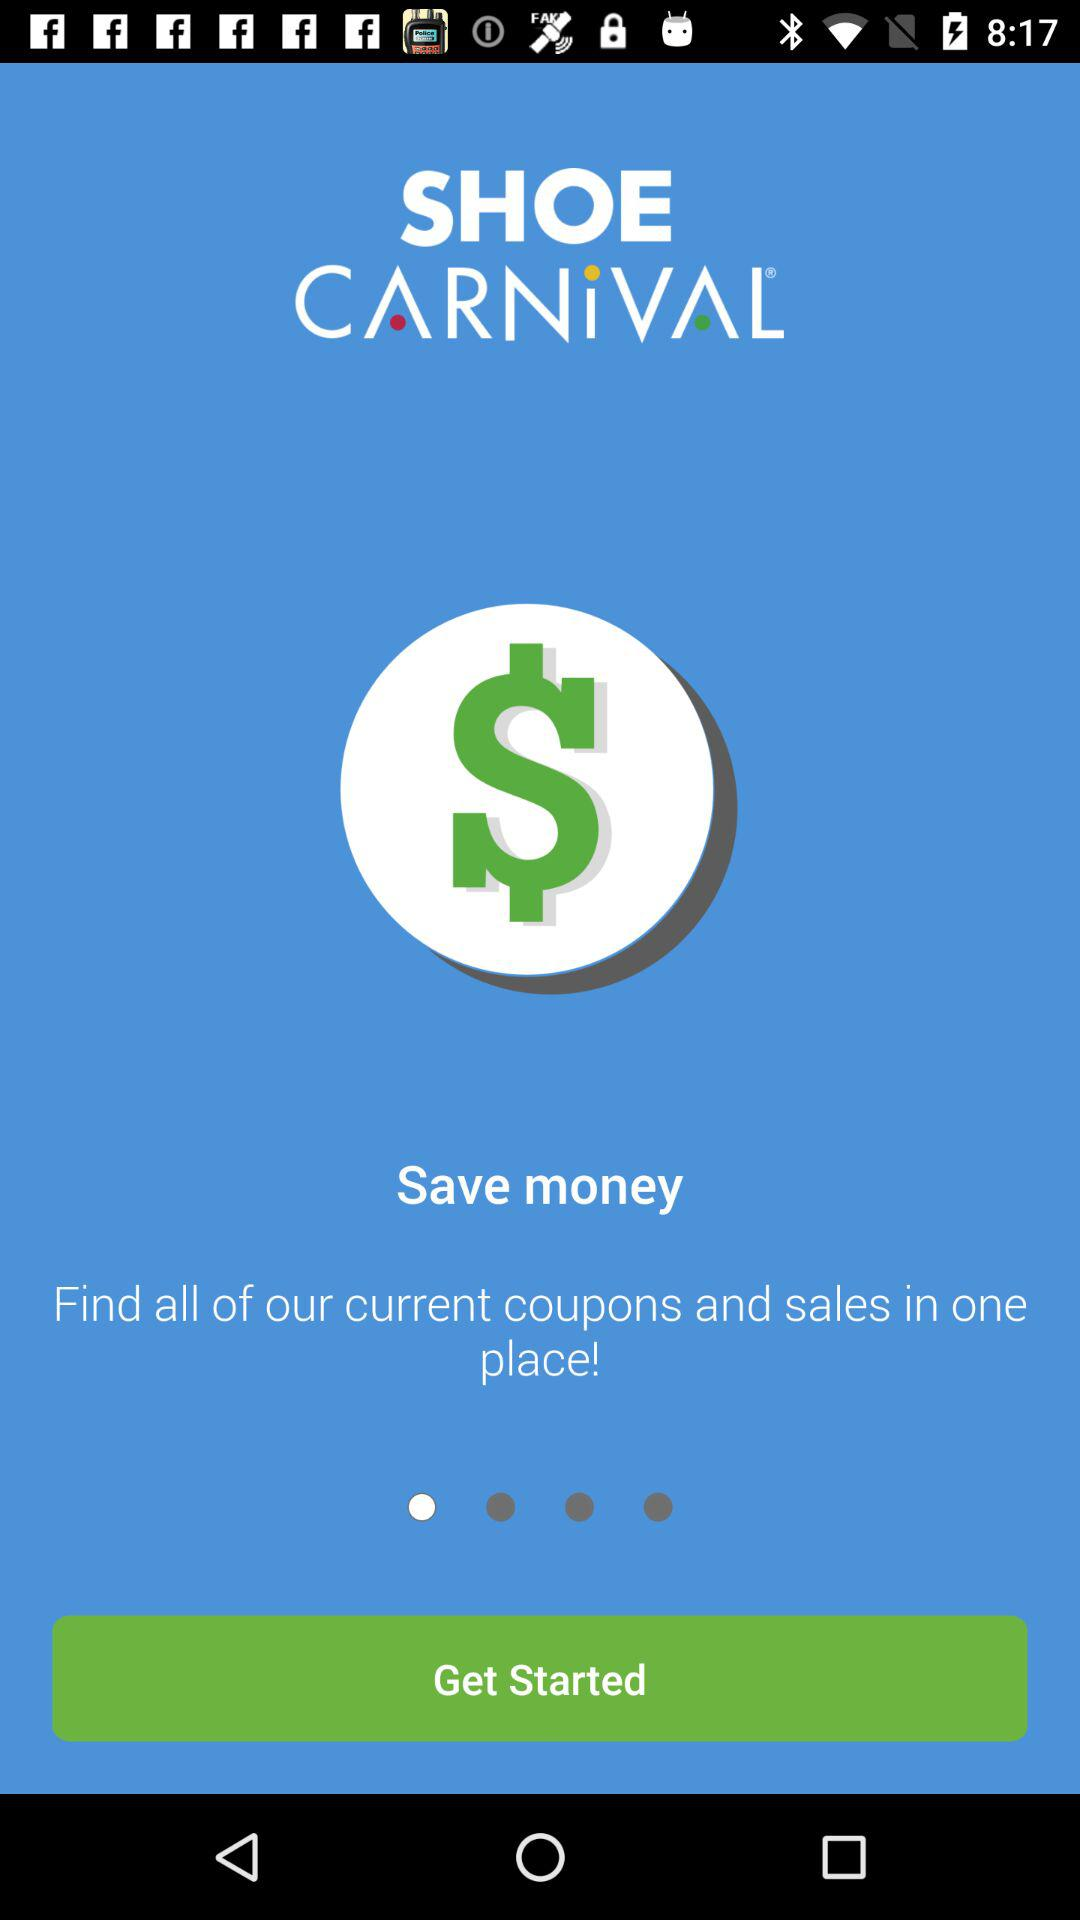What is the name of the application? The name of the application is "Shoe Carnival". 